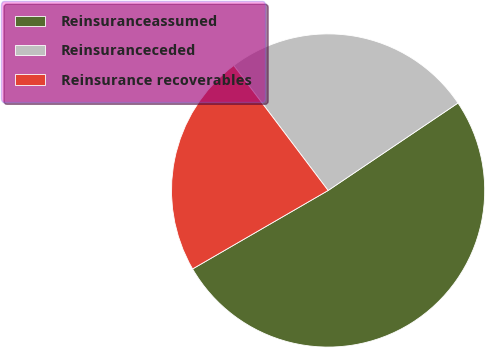Convert chart. <chart><loc_0><loc_0><loc_500><loc_500><pie_chart><fcel>Reinsuranceassumed<fcel>Reinsuranceceded<fcel>Reinsurance recoverables<nl><fcel>51.08%<fcel>25.86%<fcel>23.06%<nl></chart> 